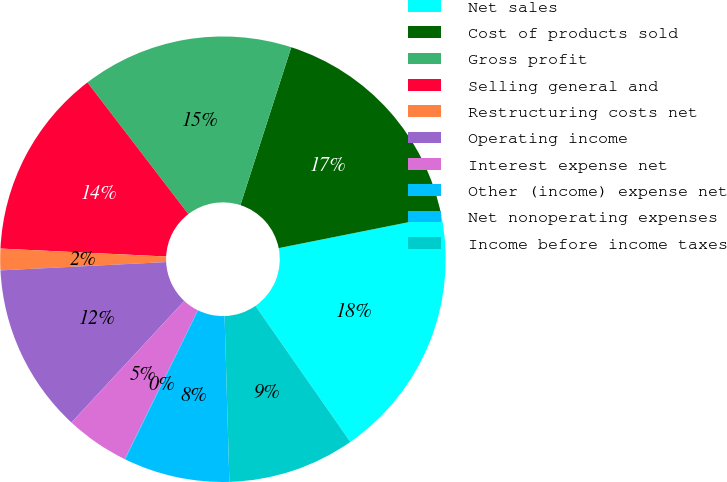<chart> <loc_0><loc_0><loc_500><loc_500><pie_chart><fcel>Net sales<fcel>Cost of products sold<fcel>Gross profit<fcel>Selling general and<fcel>Restructuring costs net<fcel>Operating income<fcel>Interest expense net<fcel>Other (income) expense net<fcel>Net nonoperating expenses<fcel>Income before income taxes<nl><fcel>18.44%<fcel>16.9%<fcel>15.37%<fcel>13.83%<fcel>1.56%<fcel>12.3%<fcel>4.63%<fcel>0.03%<fcel>7.7%<fcel>9.23%<nl></chart> 